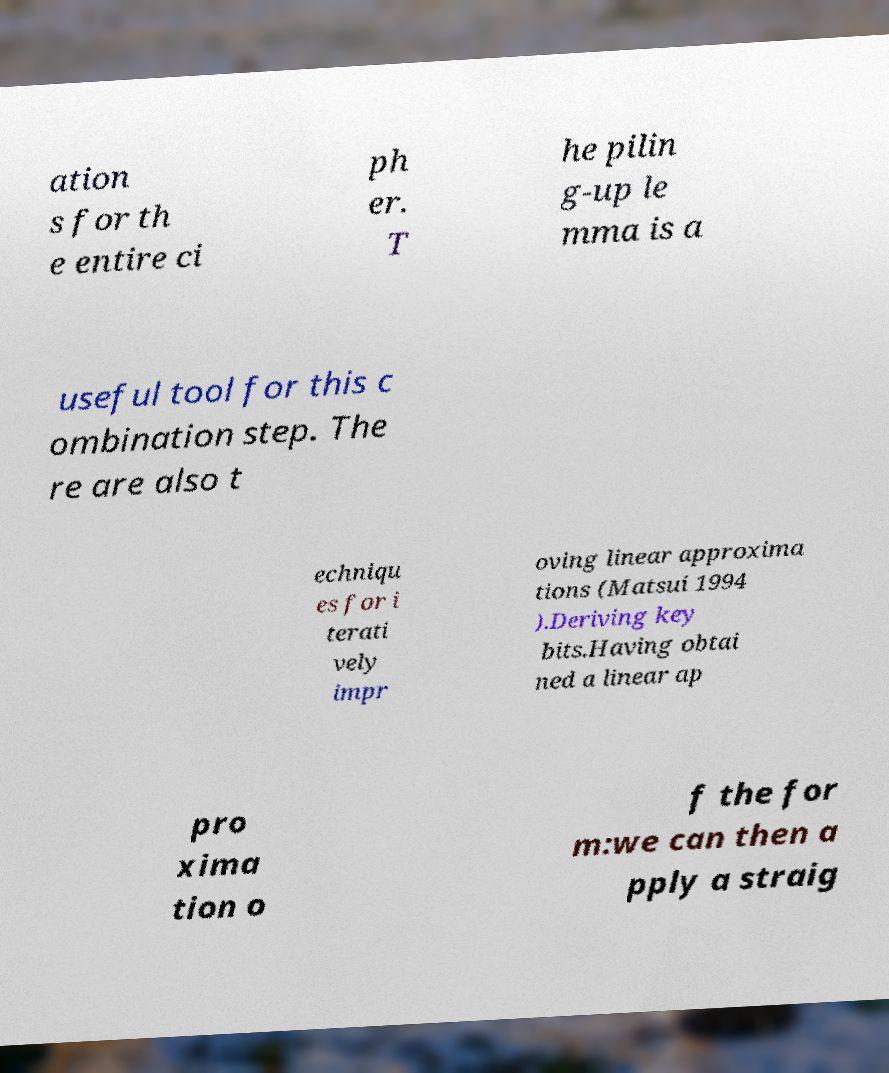For documentation purposes, I need the text within this image transcribed. Could you provide that? ation s for th e entire ci ph er. T he pilin g-up le mma is a useful tool for this c ombination step. The re are also t echniqu es for i terati vely impr oving linear approxima tions (Matsui 1994 ).Deriving key bits.Having obtai ned a linear ap pro xima tion o f the for m:we can then a pply a straig 